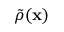<formula> <loc_0><loc_0><loc_500><loc_500>\tilde { \rho } ( \mathbf x )</formula> 